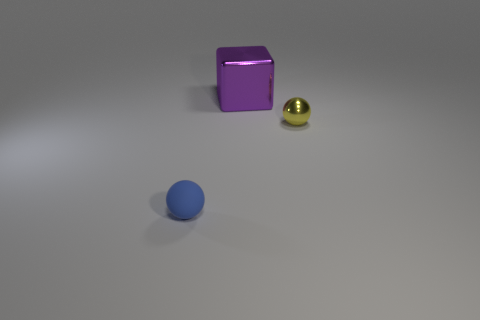Add 2 large gray balls. How many objects exist? 5 Subtract all balls. How many objects are left? 1 Add 1 small yellow shiny objects. How many small yellow shiny objects are left? 2 Add 1 big green matte cubes. How many big green matte cubes exist? 1 Subtract 0 green blocks. How many objects are left? 3 Subtract all metal blocks. Subtract all spheres. How many objects are left? 0 